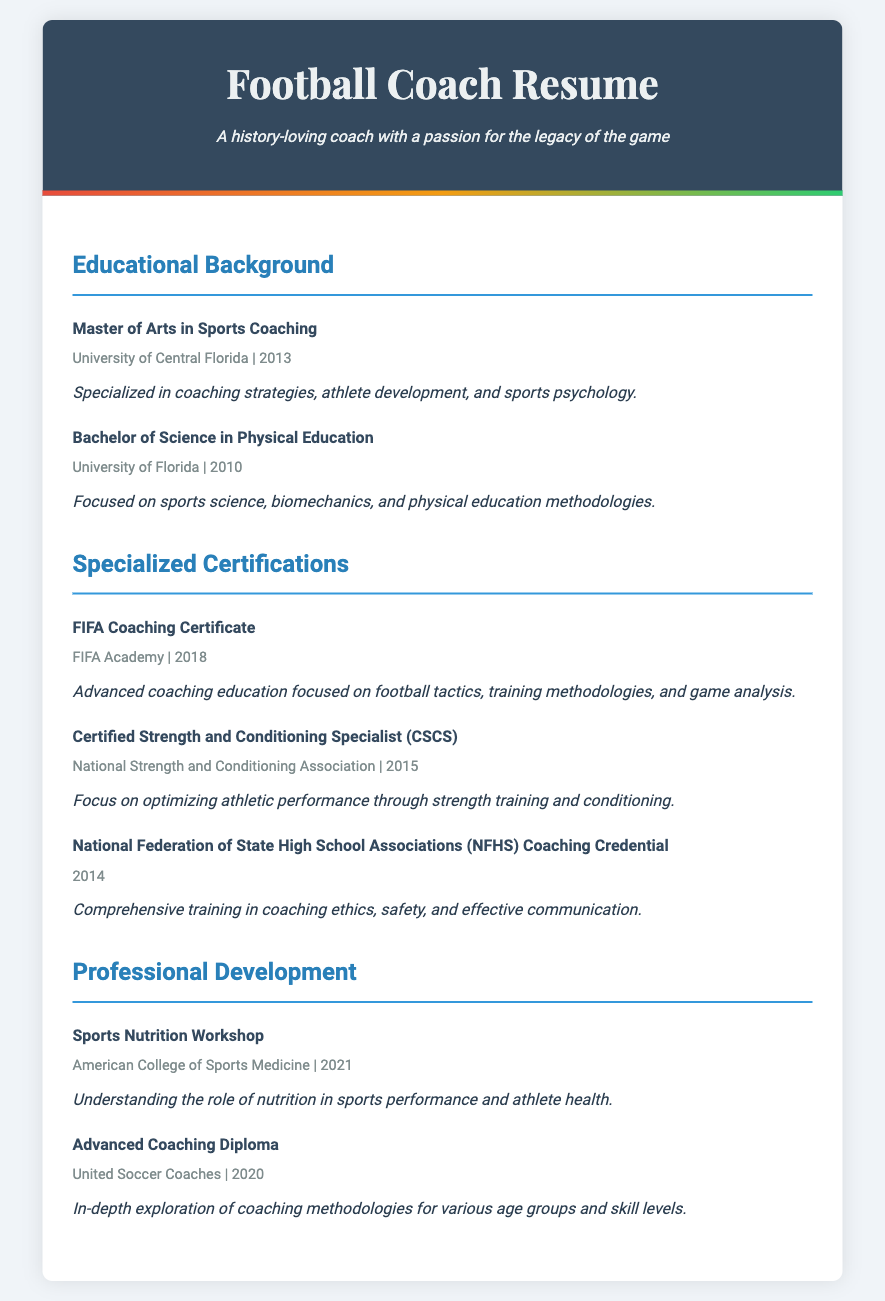What is the highest degree obtained? The highest degree mentioned in the document is the Master of Arts in Sports Coaching.
Answer: Master of Arts in Sports Coaching When did the candidate complete their Bachelor's degree? The candidate completed their Bachelor's degree in 2010, as stated in the document.
Answer: 2010 Which certification was obtained in 2018? The document lists the FIFA Coaching Certificate as the certification obtained in 2018.
Answer: FIFA Coaching Certificate What is the focus of the Certified Strength and Conditioning Specialist certification? This certification focuses on optimizing athletic performance through strength training and conditioning.
Answer: Optimizing athletic performance How many specialized certifications are listed in the document? The document lists three specialized certifications under the Specialized Certifications section.
Answer: Three What university did the candidate attend for their Master's degree? The document indicates that the candidate obtained their Master's degree from the University of Central Florida.
Answer: University of Central Florida What type of workshop did the candidate attend in 2021? The document states that the workshop attended in 2021 was a Sports Nutrition Workshop.
Answer: Sports Nutrition Workshop What does the NFHS Coaching Credential focus on? The NFHS Coaching Credential provides training in coaching ethics, safety, and effective communication.
Answer: Coaching ethics, safety, and effective communication 